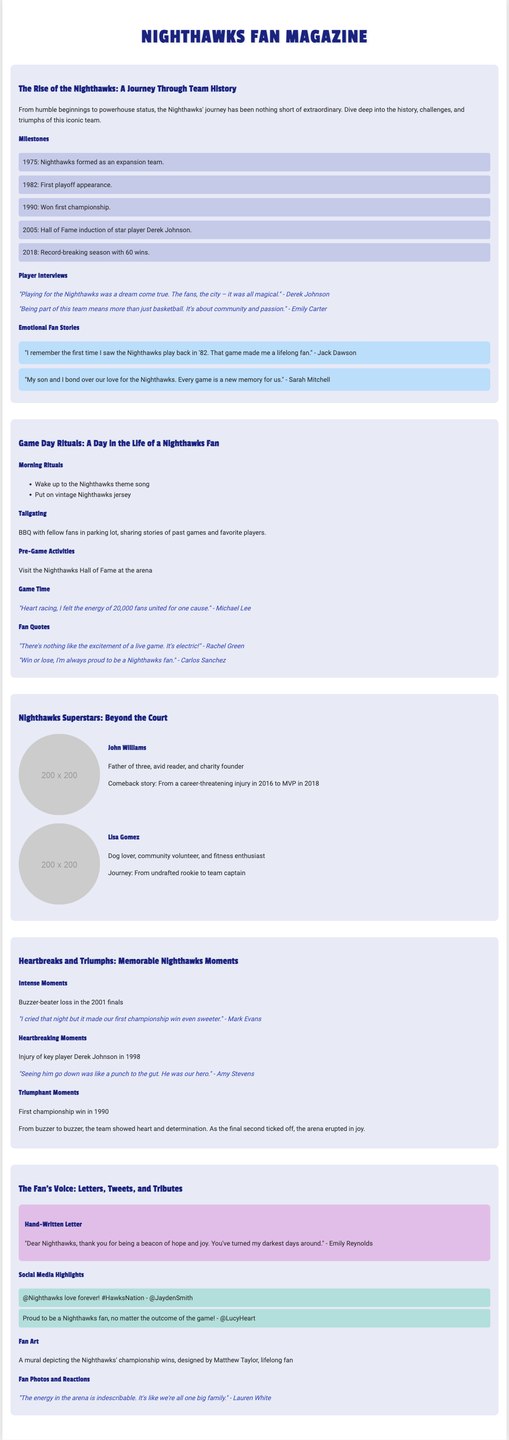What year was the Nighthawks formed? The formation year of the Nighthawks is mentioned in the milestones section of the document.
Answer: 1975 Who was inducted into the Hall of Fame in 2005? The milestone section indicates the player who was inducted into the Hall of Fame.
Answer: Derek Johnson What was the Nighthawks' record-breaking season win total? The document mentions the specific win total during the record-breaking season in 2018.
Answer: 60 wins What does John Williams do besides playing basketball? The player profile gives information about personal aspects of his life.
Answer: Charity founder What was a significant emotional moment remembered by Mark Evans? The document shares a quote that highlights a specific emotional moment.
Answer: Buzzer-beater loss in the 2001 finals Which player came back from a career-threatening injury? The player profile discusses a comeback story related to injuries.
Answer: John Williams What theme song do fans wake up to on game day? The game day rituals outline specific activities and themes associated with game day.
Answer: Nighthawks theme song What year marked the Nighthawks' first championship win? The milestones section highlights important dates in Nighthawks history, including their first championship.
Answer: 1990 What type of artworks are showcased in the fan’s voice section? The fan voice section discusses various types of fan expressions, including artworks.
Answer: Fan Art 